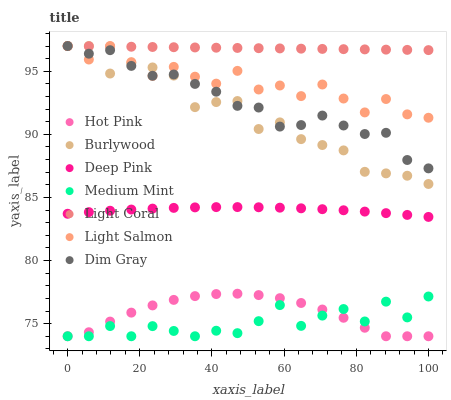Does Medium Mint have the minimum area under the curve?
Answer yes or no. Yes. Does Light Coral have the maximum area under the curve?
Answer yes or no. Yes. Does Light Salmon have the minimum area under the curve?
Answer yes or no. No. Does Light Salmon have the maximum area under the curve?
Answer yes or no. No. Is Light Coral the smoothest?
Answer yes or no. Yes. Is Light Salmon the roughest?
Answer yes or no. Yes. Is Deep Pink the smoothest?
Answer yes or no. No. Is Deep Pink the roughest?
Answer yes or no. No. Does Medium Mint have the lowest value?
Answer yes or no. Yes. Does Light Salmon have the lowest value?
Answer yes or no. No. Does Dim Gray have the highest value?
Answer yes or no. Yes. Does Deep Pink have the highest value?
Answer yes or no. No. Is Hot Pink less than Deep Pink?
Answer yes or no. Yes. Is Deep Pink greater than Medium Mint?
Answer yes or no. Yes. Does Hot Pink intersect Medium Mint?
Answer yes or no. Yes. Is Hot Pink less than Medium Mint?
Answer yes or no. No. Is Hot Pink greater than Medium Mint?
Answer yes or no. No. Does Hot Pink intersect Deep Pink?
Answer yes or no. No. 